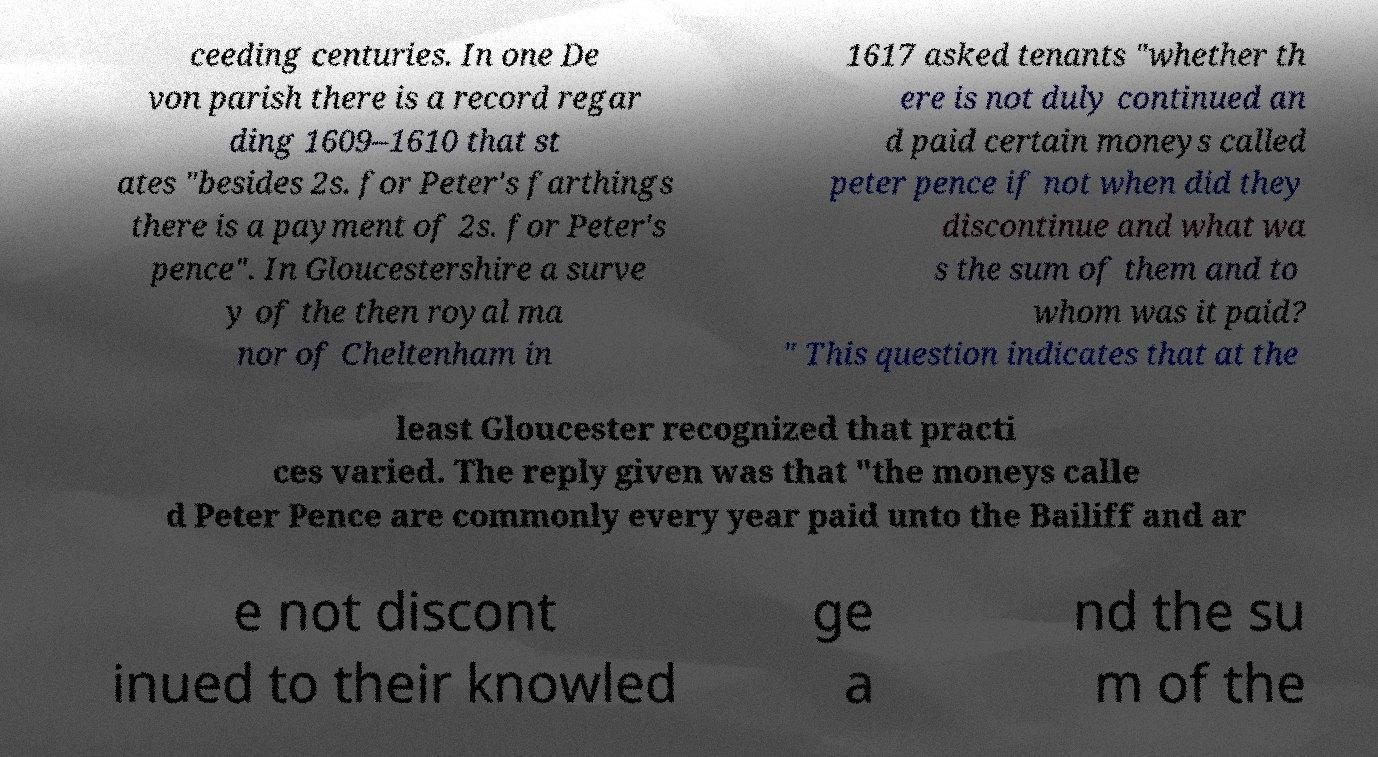Could you extract and type out the text from this image? ceeding centuries. In one De von parish there is a record regar ding 1609–1610 that st ates "besides 2s. for Peter's farthings there is a payment of 2s. for Peter's pence". In Gloucestershire a surve y of the then royal ma nor of Cheltenham in 1617 asked tenants "whether th ere is not duly continued an d paid certain moneys called peter pence if not when did they discontinue and what wa s the sum of them and to whom was it paid? " This question indicates that at the least Gloucester recognized that practi ces varied. The reply given was that "the moneys calle d Peter Pence are commonly every year paid unto the Bailiff and ar e not discont inued to their knowled ge a nd the su m of the 